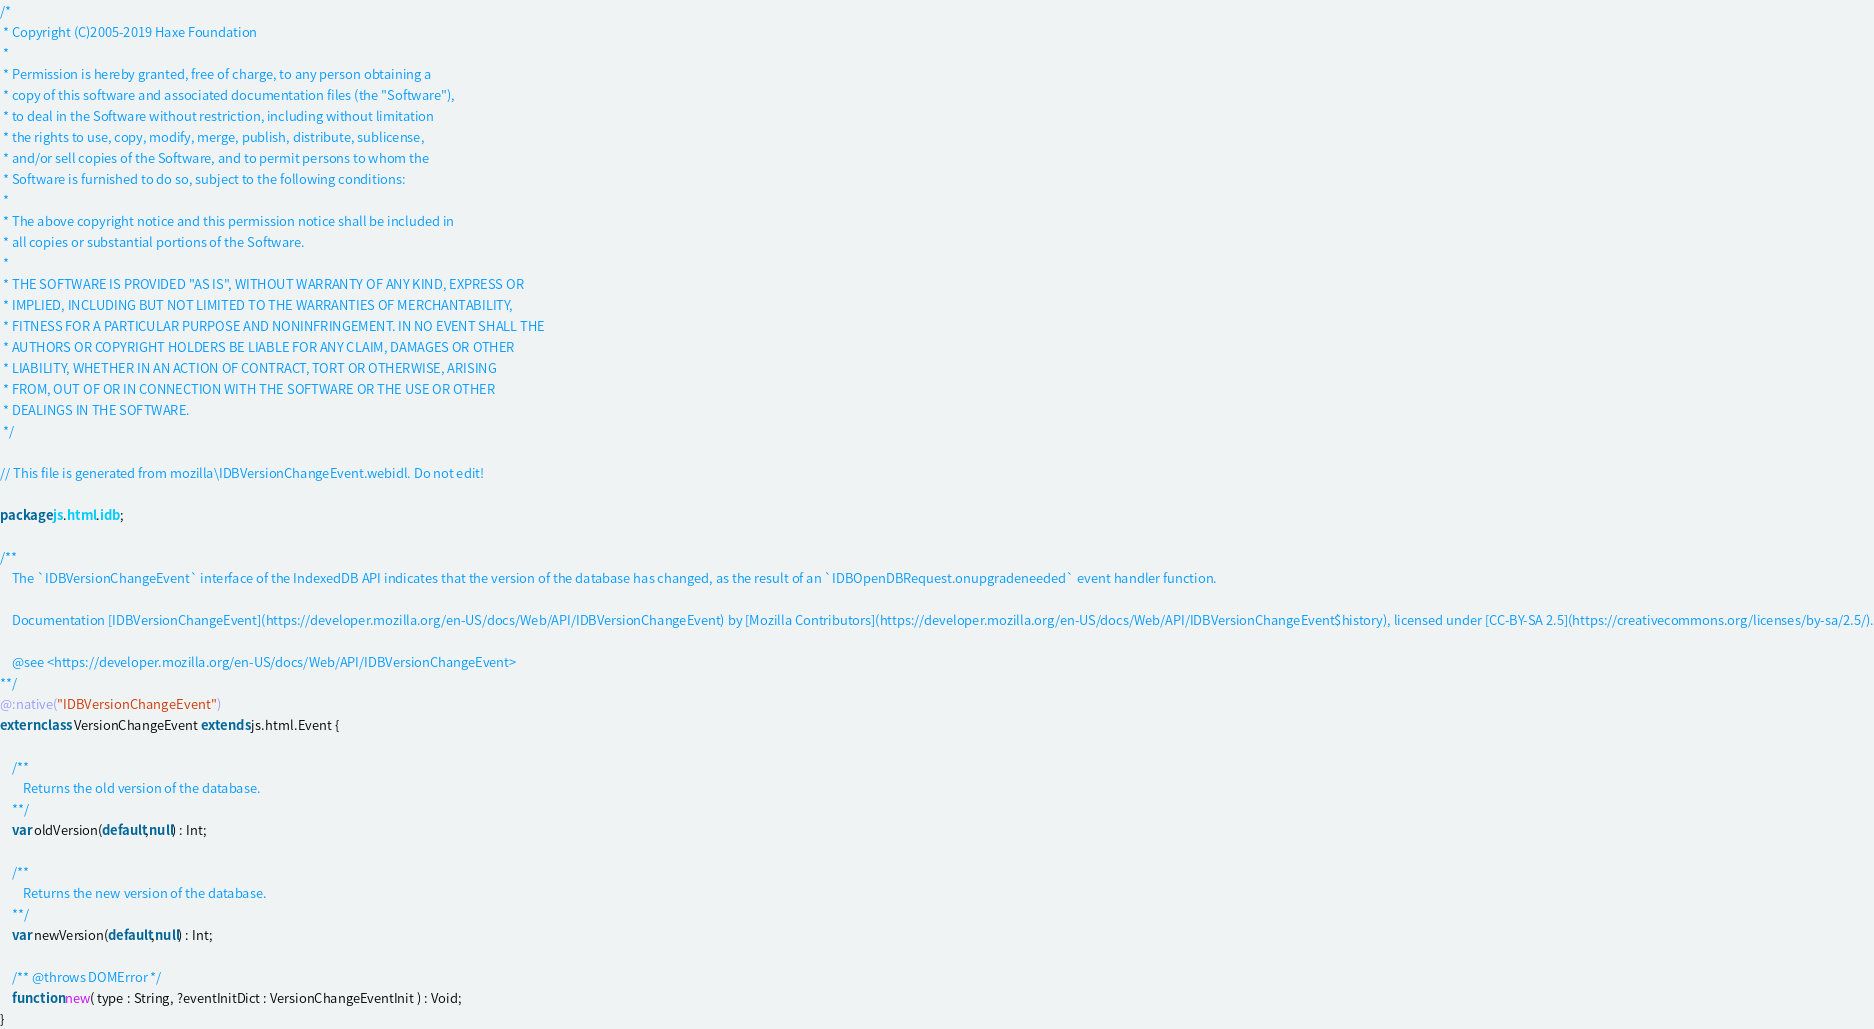<code> <loc_0><loc_0><loc_500><loc_500><_Haxe_>/*
 * Copyright (C)2005-2019 Haxe Foundation
 *
 * Permission is hereby granted, free of charge, to any person obtaining a
 * copy of this software and associated documentation files (the "Software"),
 * to deal in the Software without restriction, including without limitation
 * the rights to use, copy, modify, merge, publish, distribute, sublicense,
 * and/or sell copies of the Software, and to permit persons to whom the
 * Software is furnished to do so, subject to the following conditions:
 *
 * The above copyright notice and this permission notice shall be included in
 * all copies or substantial portions of the Software.
 *
 * THE SOFTWARE IS PROVIDED "AS IS", WITHOUT WARRANTY OF ANY KIND, EXPRESS OR
 * IMPLIED, INCLUDING BUT NOT LIMITED TO THE WARRANTIES OF MERCHANTABILITY,
 * FITNESS FOR A PARTICULAR PURPOSE AND NONINFRINGEMENT. IN NO EVENT SHALL THE
 * AUTHORS OR COPYRIGHT HOLDERS BE LIABLE FOR ANY CLAIM, DAMAGES OR OTHER
 * LIABILITY, WHETHER IN AN ACTION OF CONTRACT, TORT OR OTHERWISE, ARISING
 * FROM, OUT OF OR IN CONNECTION WITH THE SOFTWARE OR THE USE OR OTHER
 * DEALINGS IN THE SOFTWARE.
 */

// This file is generated from mozilla\IDBVersionChangeEvent.webidl. Do not edit!

package js.html.idb;

/**
	The `IDBVersionChangeEvent` interface of the IndexedDB API indicates that the version of the database has changed, as the result of an `IDBOpenDBRequest.onupgradeneeded` event handler function.

	Documentation [IDBVersionChangeEvent](https://developer.mozilla.org/en-US/docs/Web/API/IDBVersionChangeEvent) by [Mozilla Contributors](https://developer.mozilla.org/en-US/docs/Web/API/IDBVersionChangeEvent$history), licensed under [CC-BY-SA 2.5](https://creativecommons.org/licenses/by-sa/2.5/).

	@see <https://developer.mozilla.org/en-US/docs/Web/API/IDBVersionChangeEvent>
**/
@:native("IDBVersionChangeEvent")
extern class VersionChangeEvent extends js.html.Event {
	
	/**
		Returns the old version of the database.
	**/
	var oldVersion(default,null) : Int;
	
	/**
		Returns the new version of the database.
	**/
	var newVersion(default,null) : Int;
	
	/** @throws DOMError */
	function new( type : String, ?eventInitDict : VersionChangeEventInit ) : Void;
}</code> 